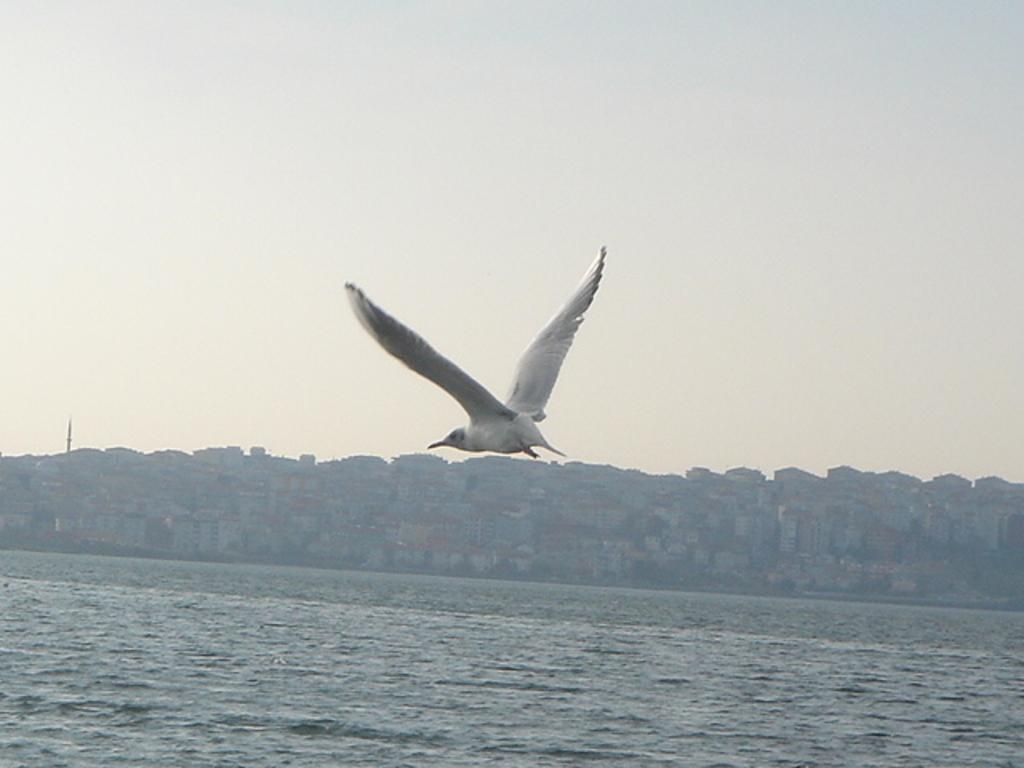What type of animal can be seen in the foreground of the image? There is a white bird in the air in the foreground of the image. What is visible in the image besides the bird? Water is visible in the image, as well as buildings and the sky in the background. How many dinosaurs can be seen in the image? There are no dinosaurs present in the image. What type of account is being discussed in the image? There is no account being discussed in the image. 